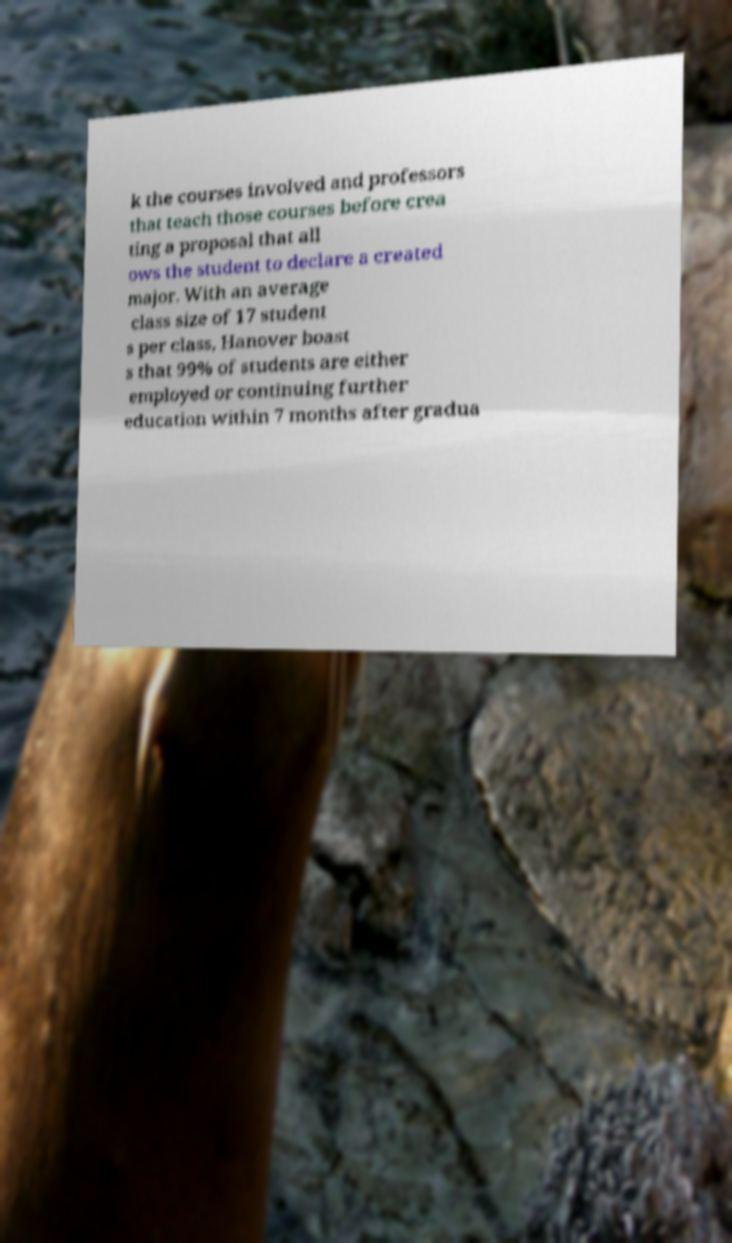Could you assist in decoding the text presented in this image and type it out clearly? k the courses involved and professors that teach those courses before crea ting a proposal that all ows the student to declare a created major. With an average class size of 17 student s per class, Hanover boast s that 99% of students are either employed or continuing further education within 7 months after gradua 